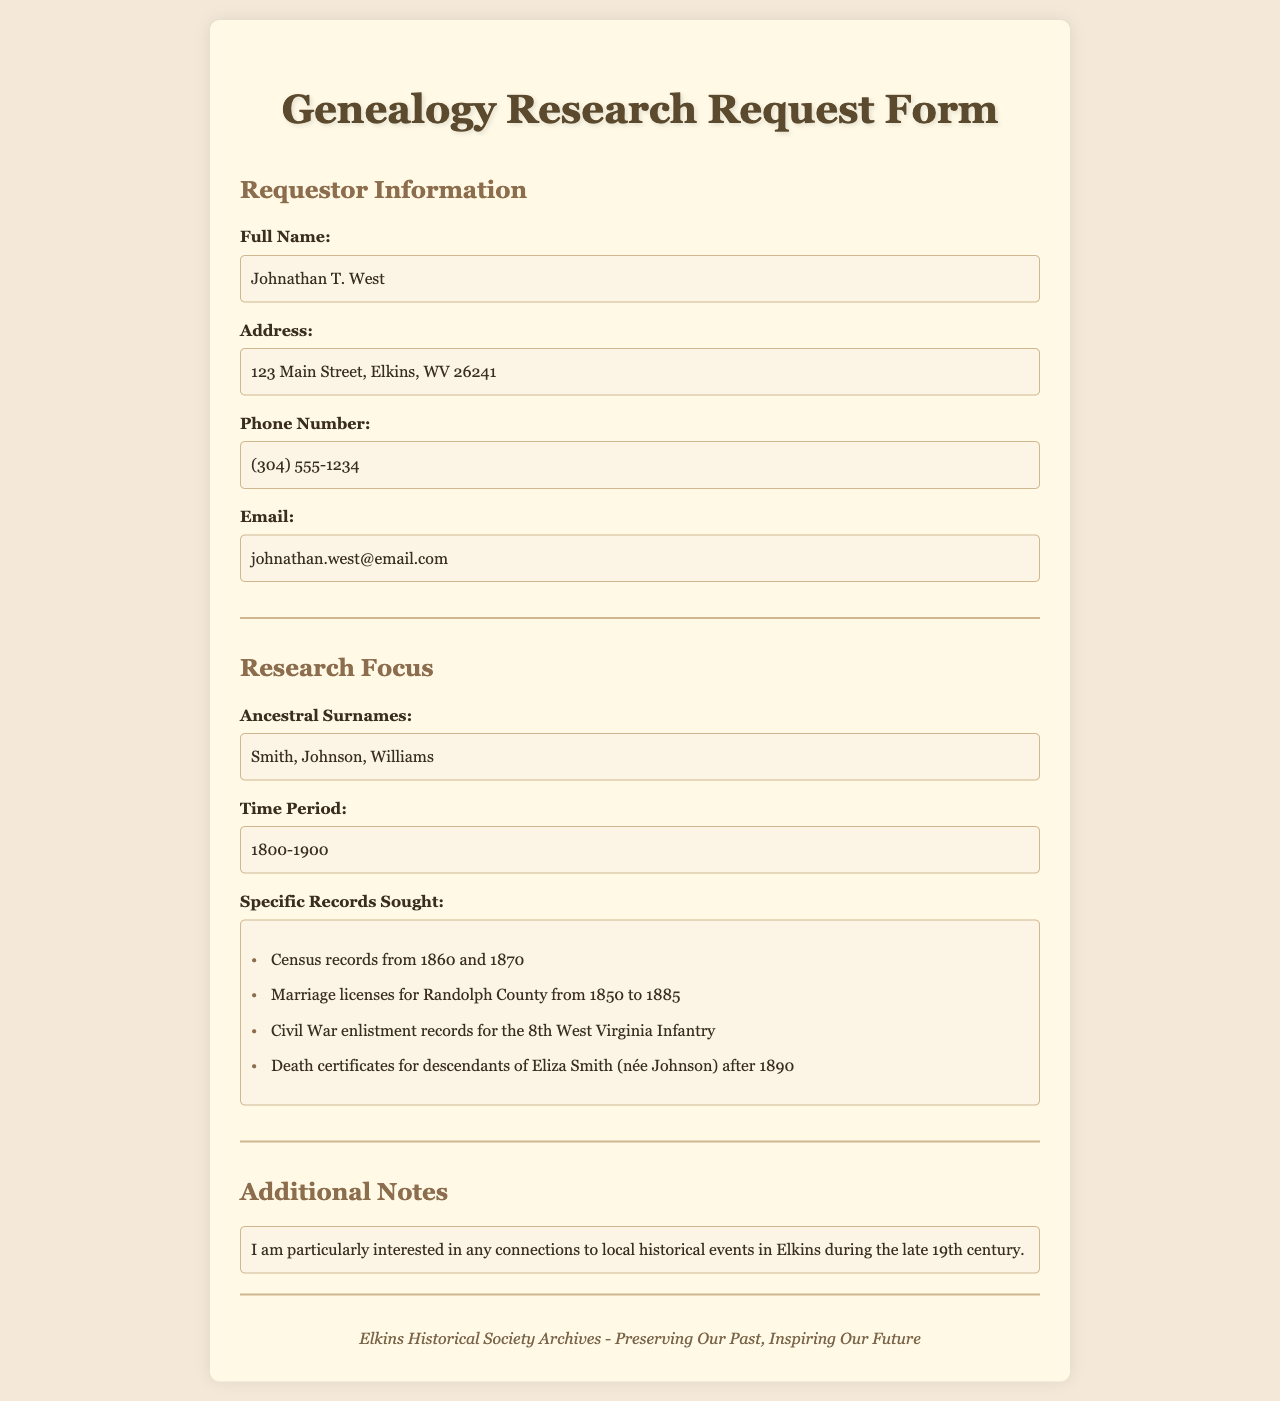what is the full name of the requestor? The requestor's full name is listed in the document under "Requestor Information."
Answer: Johnathan T. West what is the address of the requestor? The address is provided in the "Requestor Information" section.
Answer: 123 Main Street, Elkins, WV 26241 what time period is the research focused on? The time period for the research focus is clearly stated in the document.
Answer: 1800-1900 what specific records are sought related to marriage licenses? The details of the specific records sought for marriage licenses are mentioned in the "Research Focus" section.
Answer: Marriage licenses for Randolph County from 1850 to 1885 how many ancestral surnames are mentioned? The document lists a specific number of ancestral surnames in the "Research Focus" section.
Answer: Three what additional interests does the requestor have regarding local history? Additional notes regarding interest in local history are found in the "Additional Notes" section.
Answer: Connections to local historical events in Elkins during the late 19th century which Civil War regiment's enlistment records are sought? The specific Civil War regiment mentioned is found in the "Specific Records Sought" list.
Answer: 8th West Virginia Infantry what phone number is provided by the requestor? The requestor's phone number is included in the "Requestor Information" section.
Answer: (304) 555-1234 what type of document is this form? This form is filled out for a specific purpose mentioned in the title.
Answer: Genealogy Research Request Form 